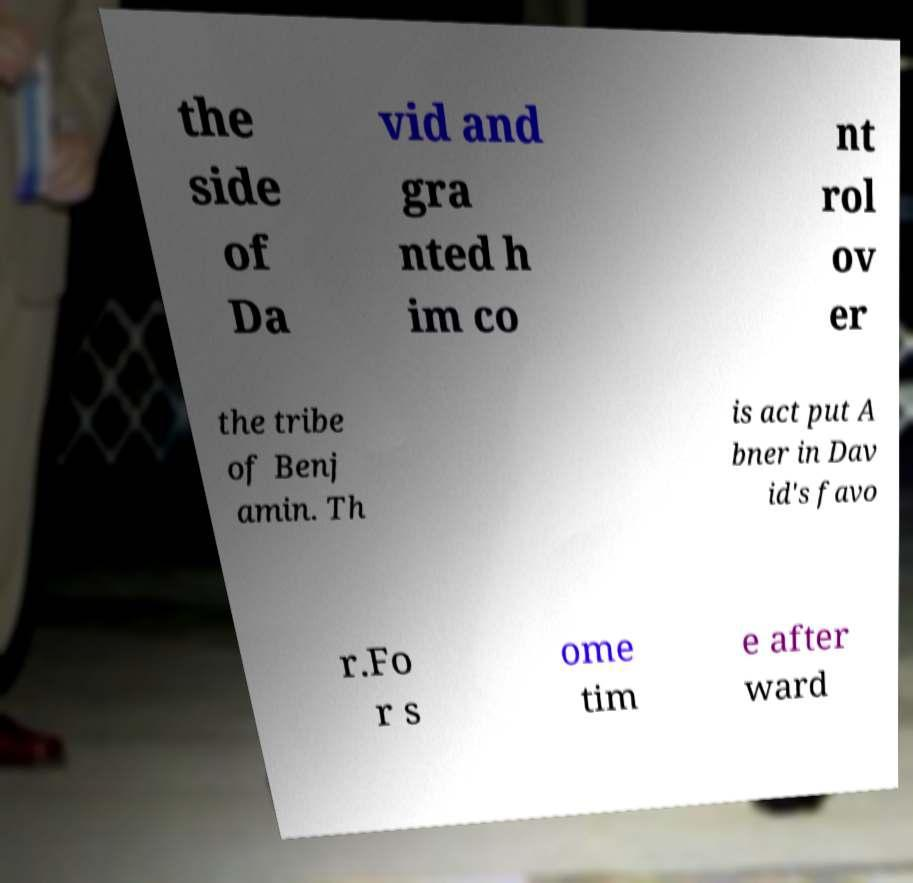Could you extract and type out the text from this image? the side of Da vid and gra nted h im co nt rol ov er the tribe of Benj amin. Th is act put A bner in Dav id's favo r.Fo r s ome tim e after ward 